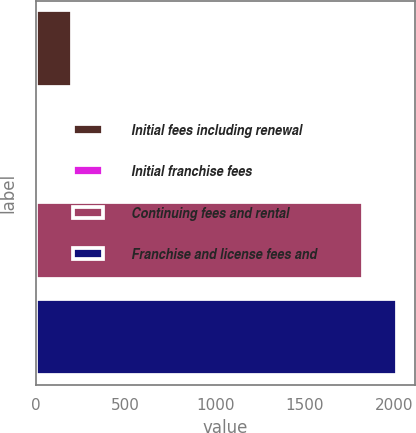<chart> <loc_0><loc_0><loc_500><loc_500><bar_chart><fcel>Initial fees including renewal<fcel>Initial franchise fees<fcel>Continuing fees and rental<fcel>Franchise and license fees and<nl><fcel>201.7<fcel>13<fcel>1823<fcel>2011.7<nl></chart> 